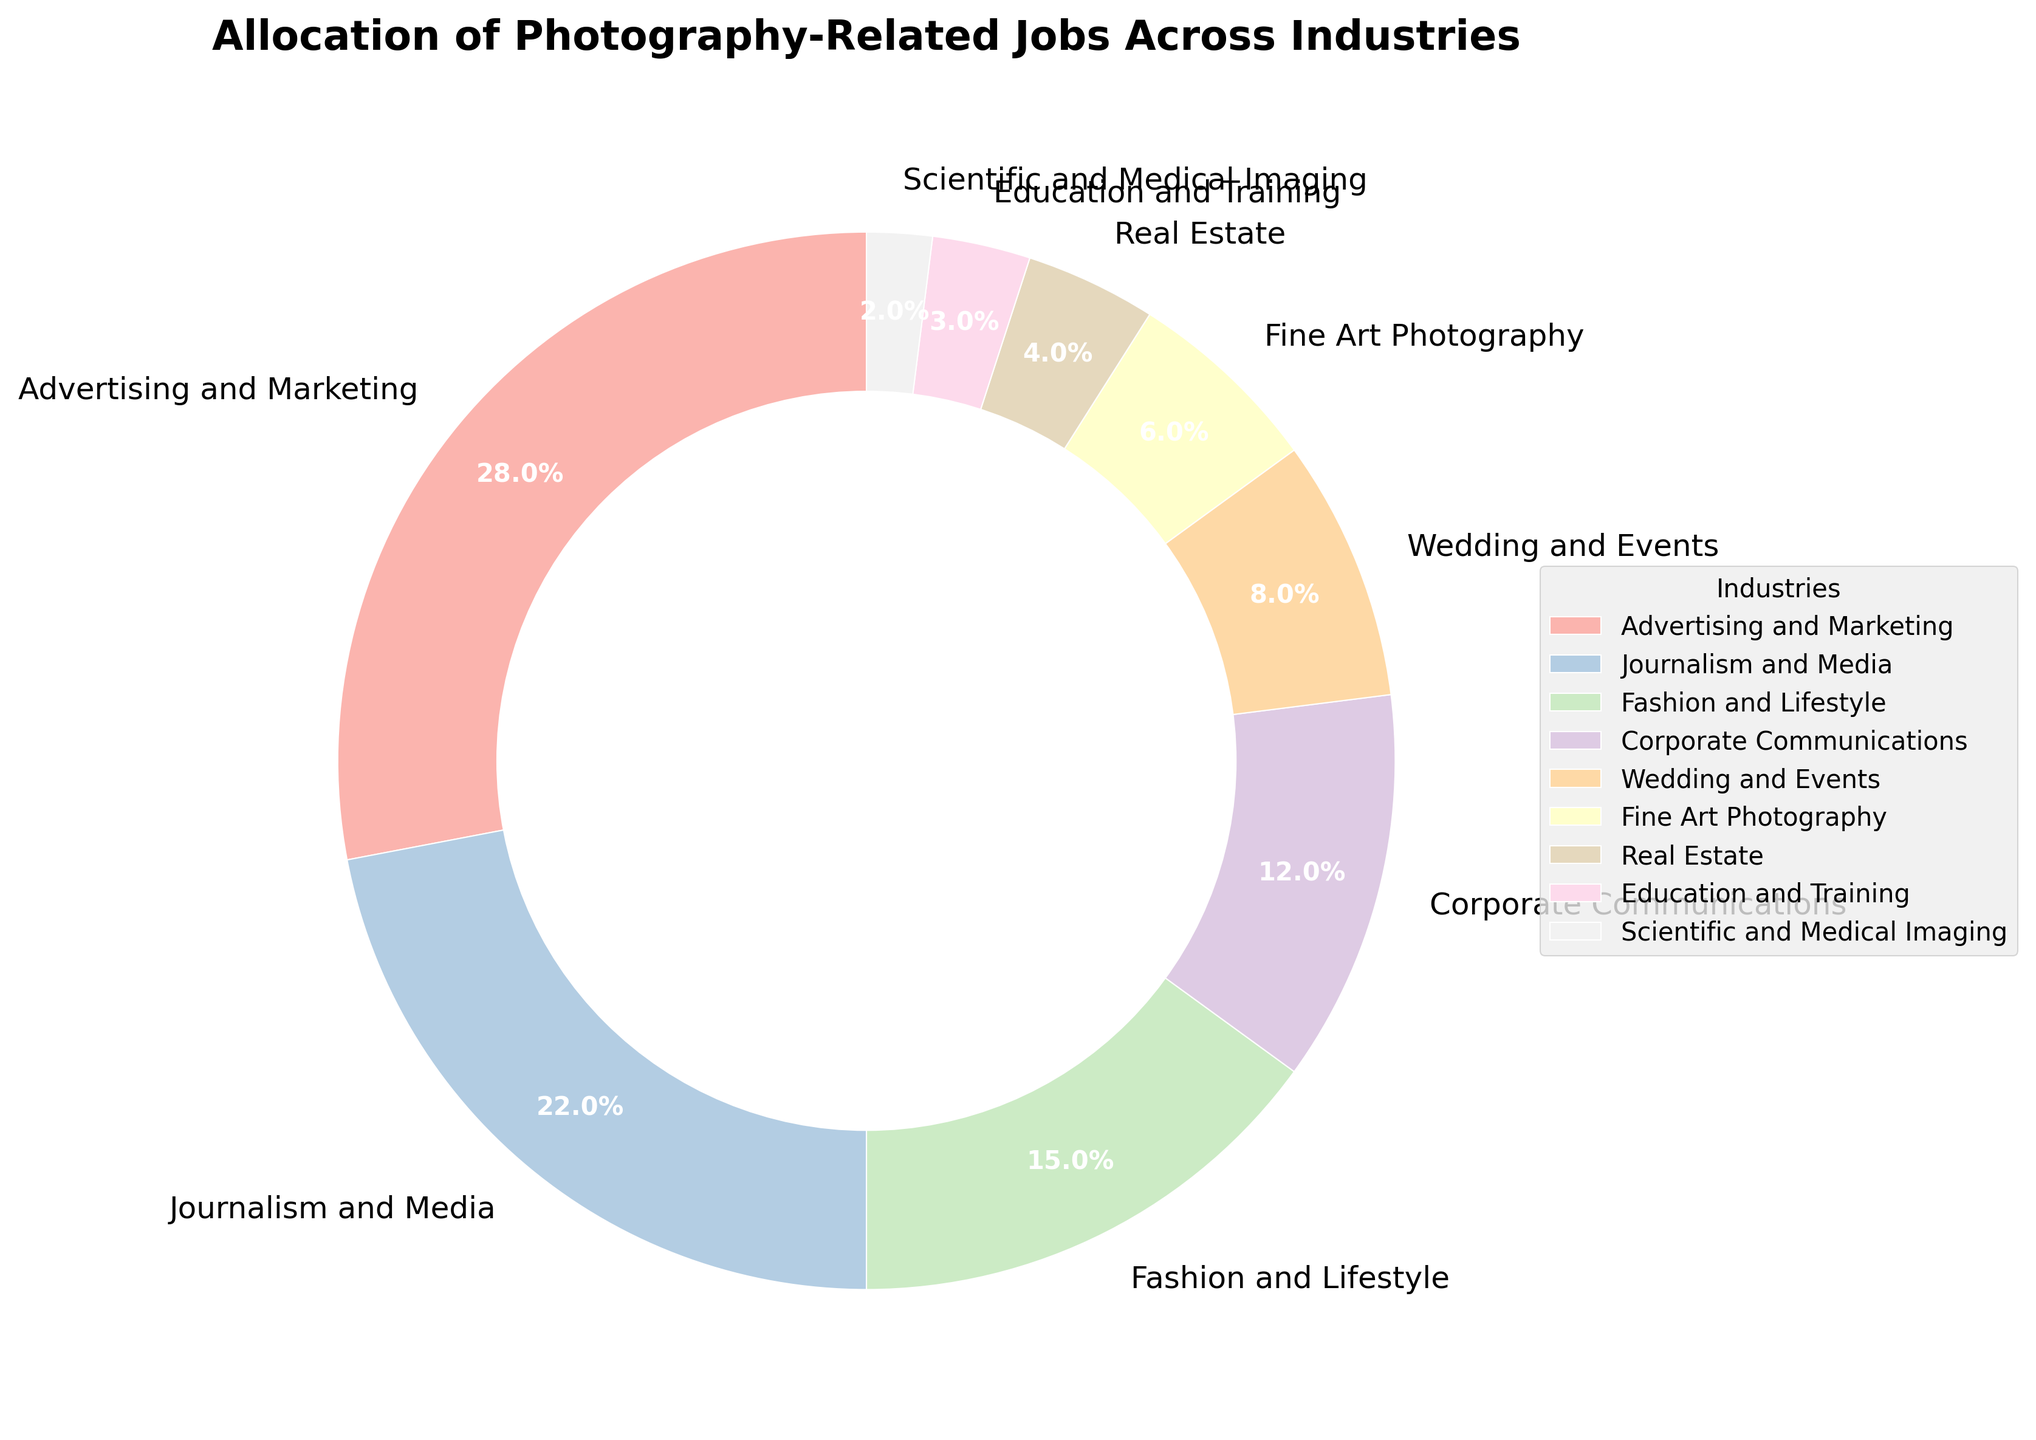Which industry has the highest allocation of photography-related jobs? The pie chart shows different industries with various segments representing their job allocation. The section labeled "Advertising and Marketing" is the largest.
Answer: Advertising and Marketing How much greater is the percentage of jobs in Advertising and Marketing compared to Real Estate? The percentage for Advertising and Marketing is 28%, and for Real Estate, it is 4%. Subtracting these values gives us 28% - 4% = 24%.
Answer: 24% What is the combined percentage of jobs in Journalism and Media and Fashion and Lifestyle? The percentages for Journalism and Media and Fashion and Lifestyle are 22% and 15%, respectively. Adding them gives us 22% + 15% = 37%.
Answer: 37% How does the allocation in Fine Art Photography compare to that in Corporate Communications? Fine Art Photography has a job allocation of 6%, while Corporate Communications has 12%. Fine Art Photography has half the allocation of Corporate Communications.
Answer: Half Which two industries together constitute more than 40% of the photography-related jobs? Advertising and Marketing (28%) and Journalism and Media (22%) together make 50%, which is more than 40%.
Answer: Advertising and Marketing; Journalism and Media How many industries have an allocation of less than 10% for photography-related jobs? From the chart, the industries with less than 10% allocation are Wedding and Events (8%), Fine Art Photography (6%), Real Estate (4%), Education and Training (3%), and Scientific and Medical Imaging (2%), totaling 5 industries.
Answer: 5 What percentage of photography-related jobs are in industries other than Advertising and Marketing and Journalism and Media? The total from other industries is calculated by subtracting the sum of Advertising and Marketing (28%) and Journalism and Media (22%) from 100%. 100% - 28% - 22% = 50%.
Answer: 50% If Education and Training increases its job allocation to equal Wedding and Events, what would be the combined percentage of the two industries? Currently, Education and Training has 3%, and Wedding and Events has 8%. If Education and Training rises to 8%, their combined percentage would be 8% + 8% = 16%.
Answer: 16% Which industry has the smallest allocation of photography-related jobs? The smallest allocation is represented by the smallest segment on the pie chart, labeled as "Scientific and Medical Imaging" with 2%.
Answer: Scientific and Medical Imaging What's the ratio of the percentage allocation of Fine Art Photography to Real Estate? Fine Art Photography has 6%, and Real Estate has 4%. The ratio is 6:4, which can be simplified to 3:2.
Answer: 3:2 